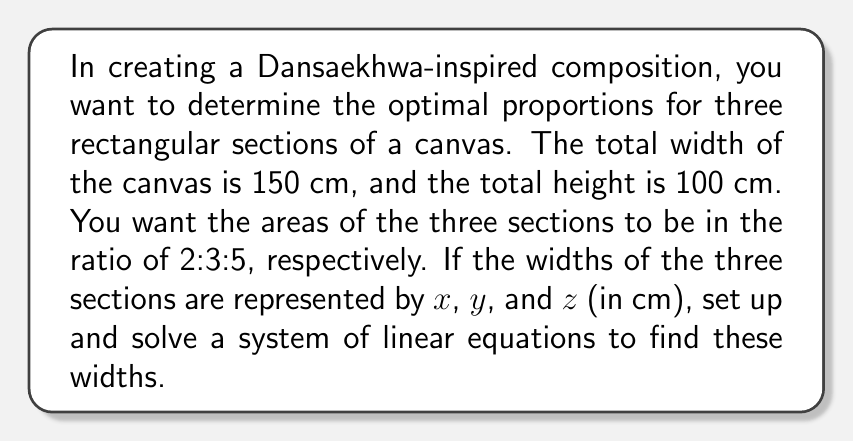Show me your answer to this math problem. Let's approach this step-by-step:

1) First, we know that the sum of the widths must equal the total width of the canvas:

   $$x + y + z = 150$$

2) Now, let's consider the areas. If the height is 100 cm, the areas of the three sections are:

   Section 1: $100x$
   Section 2: $100y$
   Section 3: $100z$

3) We're told that these areas should be in the ratio 2:3:5. We can express this as:

   $$100x : 100y : 100z = 2 : 3 : 5$$

4) This gives us two more equations:

   $$\frac{100x}{2} = \frac{100y}{3} = \frac{100z}{5}$$

5) Let's simplify by removing the common factor of 100:

   $$\frac{x}{2} = \frac{y}{3} = \frac{z}{5}$$

6) From this, we can derive two more equations:

   $$3x = 2y$$ 
   $$5x = 2z$$

7) Now we have a system of three linear equations:

   $$x + y + z = 150$$
   $$3x - 2y = 0$$
   $$5x - 2z = 0$$

8) We can solve this system using substitution or elimination. Let's use substitution:

   From the second equation: $y = \frac{3x}{2}$
   From the third equation: $z = \frac{5x}{2}$

9) Substituting these into the first equation:

   $$x + \frac{3x}{2} + \frac{5x}{2} = 150$$

10) Simplifying:

    $$x + \frac{8x}{2} = 150$$
    $$5x = 150$$
    $$x = 30$$

11) Now we can find $y$ and $z$:

    $$y = \frac{3x}{2} = \frac{3(30)}{2} = 45$$
    $$z = \frac{5x}{2} = \frac{5(30)}{2} = 75$$

12) Let's verify that these satisfy our original conditions:

    - Sum of widths: $30 + 45 + 75 = 150$ ✓
    - Ratio of areas: $30 : 45 : 75 = 2 : 3 : 5$ ✓
Answer: The optimal widths for the three sections are:
$x = 30$ cm, $y = 45$ cm, and $z = 75$ cm. 